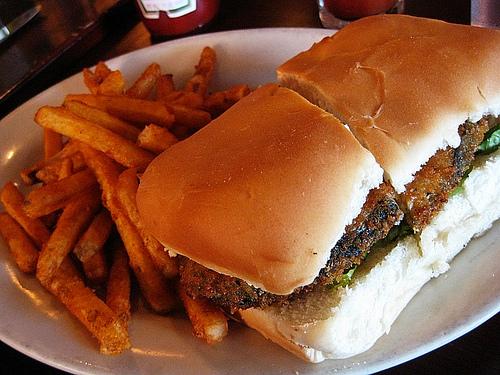Can the diner use ketchup?
Keep it brief. Yes. Are there French fries?
Concise answer only. Yes. Which of these foods is grown in the ground?
Concise answer only. Fries. Is the sandwich cut in half?
Give a very brief answer. Yes. 